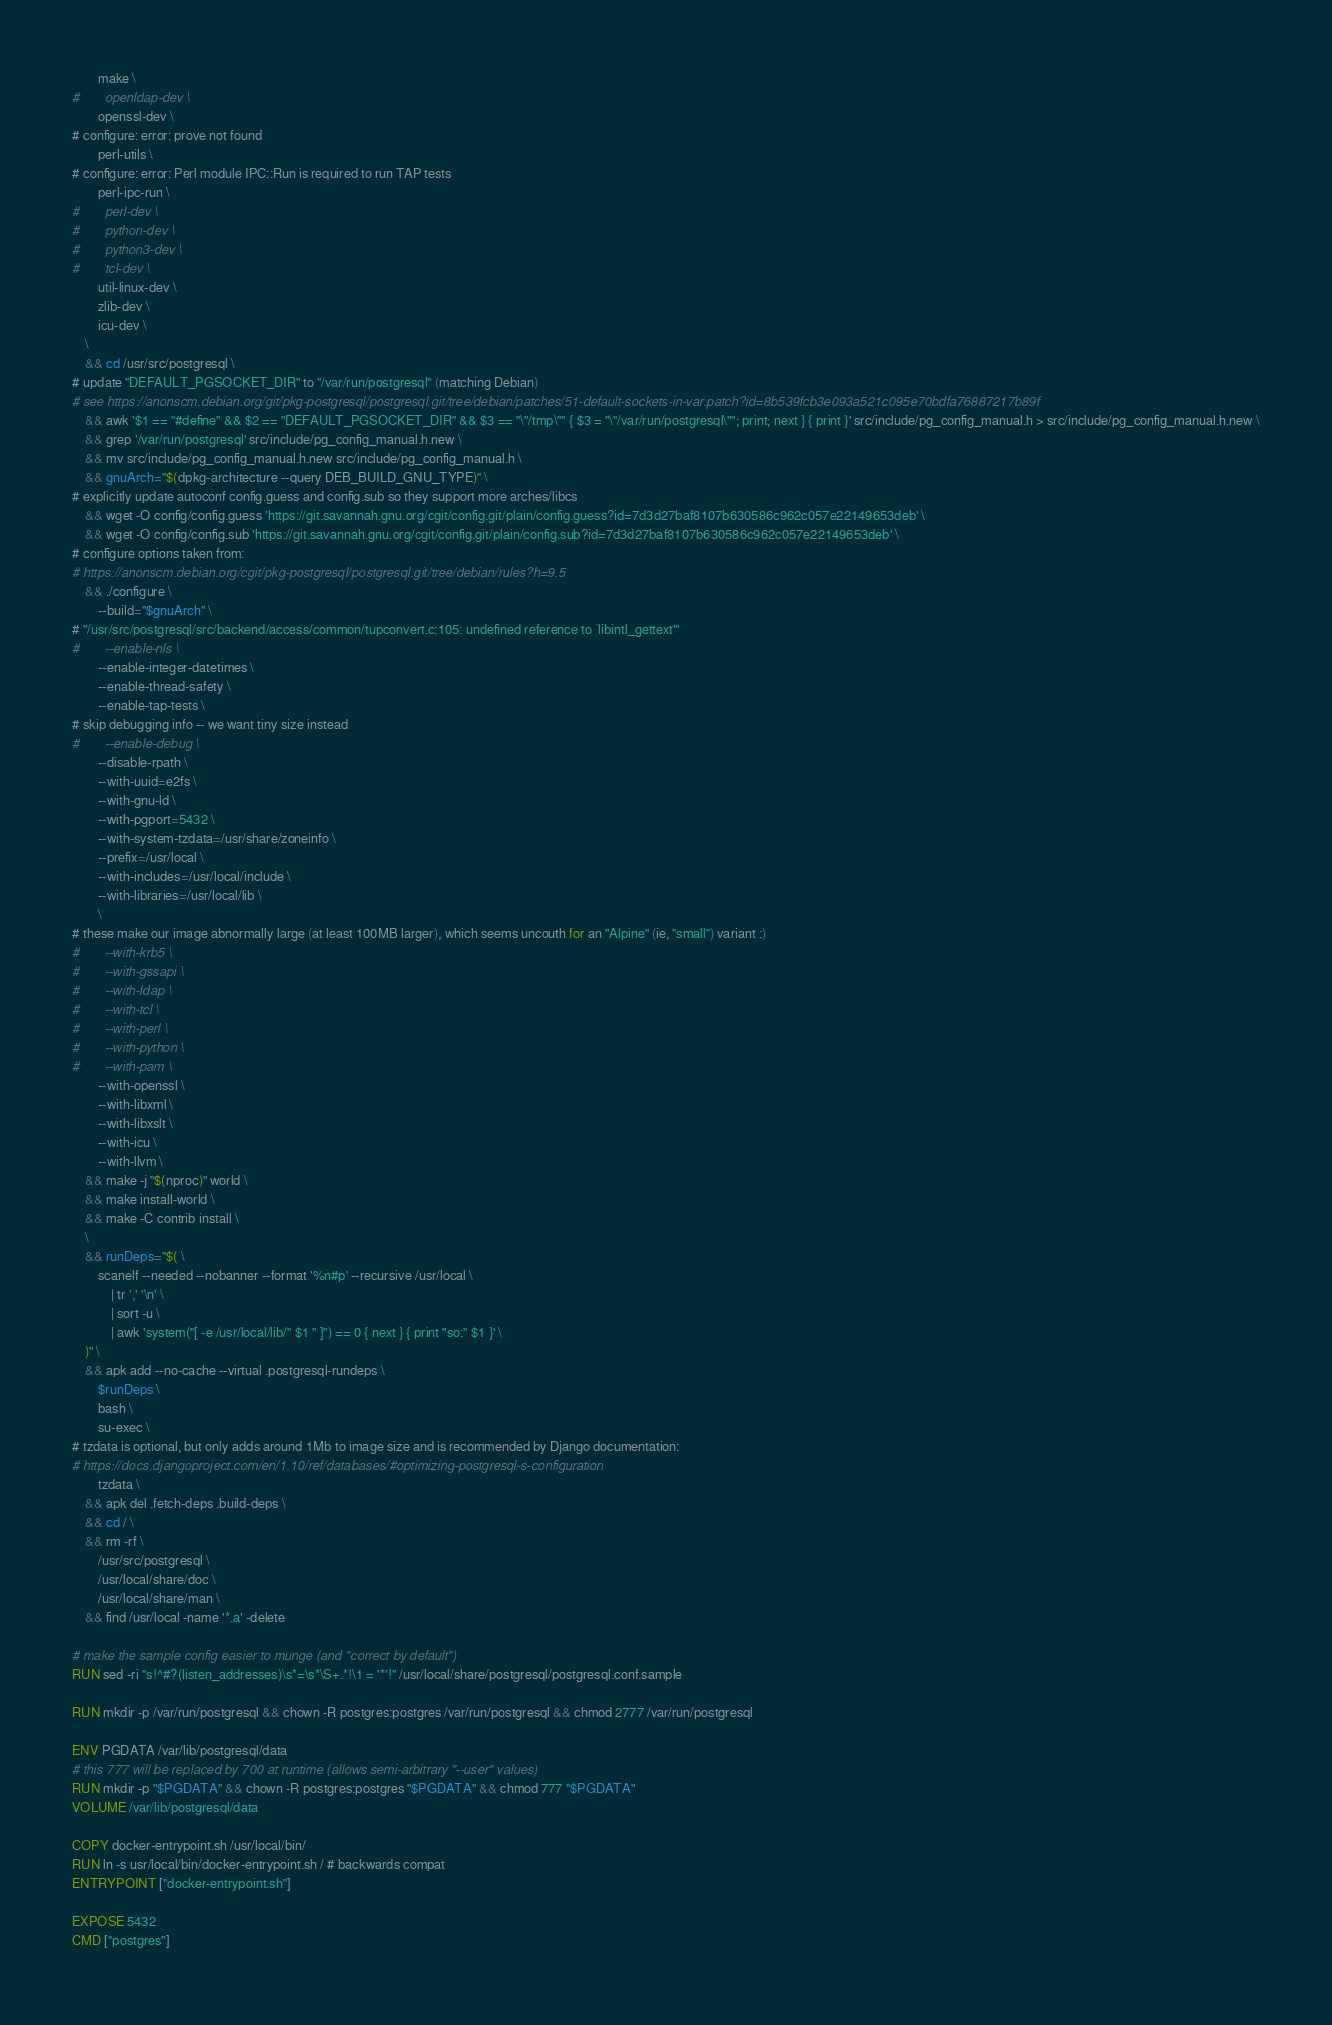<code> <loc_0><loc_0><loc_500><loc_500><_Dockerfile_>		make \
#		openldap-dev \
		openssl-dev \
# configure: error: prove not found
		perl-utils \
# configure: error: Perl module IPC::Run is required to run TAP tests
		perl-ipc-run \
#		perl-dev \
#		python-dev \
#		python3-dev \
#		tcl-dev \
		util-linux-dev \
		zlib-dev \
		icu-dev \
	\
	&& cd /usr/src/postgresql \
# update "DEFAULT_PGSOCKET_DIR" to "/var/run/postgresql" (matching Debian)
# see https://anonscm.debian.org/git/pkg-postgresql/postgresql.git/tree/debian/patches/51-default-sockets-in-var.patch?id=8b539fcb3e093a521c095e70bdfa76887217b89f
	&& awk '$1 == "#define" && $2 == "DEFAULT_PGSOCKET_DIR" && $3 == "\"/tmp\"" { $3 = "\"/var/run/postgresql\""; print; next } { print }' src/include/pg_config_manual.h > src/include/pg_config_manual.h.new \
	&& grep '/var/run/postgresql' src/include/pg_config_manual.h.new \
	&& mv src/include/pg_config_manual.h.new src/include/pg_config_manual.h \
	&& gnuArch="$(dpkg-architecture --query DEB_BUILD_GNU_TYPE)" \
# explicitly update autoconf config.guess and config.sub so they support more arches/libcs
	&& wget -O config/config.guess 'https://git.savannah.gnu.org/cgit/config.git/plain/config.guess?id=7d3d27baf8107b630586c962c057e22149653deb' \
	&& wget -O config/config.sub 'https://git.savannah.gnu.org/cgit/config.git/plain/config.sub?id=7d3d27baf8107b630586c962c057e22149653deb' \
# configure options taken from:
# https://anonscm.debian.org/cgit/pkg-postgresql/postgresql.git/tree/debian/rules?h=9.5
	&& ./configure \
		--build="$gnuArch" \
# "/usr/src/postgresql/src/backend/access/common/tupconvert.c:105: undefined reference to `libintl_gettext'"
#		--enable-nls \
		--enable-integer-datetimes \
		--enable-thread-safety \
		--enable-tap-tests \
# skip debugging info -- we want tiny size instead
#		--enable-debug \
		--disable-rpath \
		--with-uuid=e2fs \
		--with-gnu-ld \
		--with-pgport=5432 \
		--with-system-tzdata=/usr/share/zoneinfo \
		--prefix=/usr/local \
		--with-includes=/usr/local/include \
		--with-libraries=/usr/local/lib \
		\
# these make our image abnormally large (at least 100MB larger), which seems uncouth for an "Alpine" (ie, "small") variant :)
#		--with-krb5 \
#		--with-gssapi \
#		--with-ldap \
#		--with-tcl \
#		--with-perl \
#		--with-python \
#		--with-pam \
		--with-openssl \
		--with-libxml \
		--with-libxslt \
		--with-icu \
		--with-llvm \
	&& make -j "$(nproc)" world \
	&& make install-world \
	&& make -C contrib install \
	\
	&& runDeps="$( \
		scanelf --needed --nobanner --format '%n#p' --recursive /usr/local \
			| tr ',' '\n' \
			| sort -u \
			| awk 'system("[ -e /usr/local/lib/" $1 " ]") == 0 { next } { print "so:" $1 }' \
	)" \
	&& apk add --no-cache --virtual .postgresql-rundeps \
		$runDeps \
		bash \
		su-exec \
# tzdata is optional, but only adds around 1Mb to image size and is recommended by Django documentation:
# https://docs.djangoproject.com/en/1.10/ref/databases/#optimizing-postgresql-s-configuration
		tzdata \
	&& apk del .fetch-deps .build-deps \
	&& cd / \
	&& rm -rf \
		/usr/src/postgresql \
		/usr/local/share/doc \
		/usr/local/share/man \
	&& find /usr/local -name '*.a' -delete

# make the sample config easier to munge (and "correct by default")
RUN sed -ri "s!^#?(listen_addresses)\s*=\s*\S+.*!\1 = '*'!" /usr/local/share/postgresql/postgresql.conf.sample

RUN mkdir -p /var/run/postgresql && chown -R postgres:postgres /var/run/postgresql && chmod 2777 /var/run/postgresql

ENV PGDATA /var/lib/postgresql/data
# this 777 will be replaced by 700 at runtime (allows semi-arbitrary "--user" values)
RUN mkdir -p "$PGDATA" && chown -R postgres:postgres "$PGDATA" && chmod 777 "$PGDATA"
VOLUME /var/lib/postgresql/data

COPY docker-entrypoint.sh /usr/local/bin/
RUN ln -s usr/local/bin/docker-entrypoint.sh / # backwards compat
ENTRYPOINT ["docker-entrypoint.sh"]

EXPOSE 5432
CMD ["postgres"]
</code> 